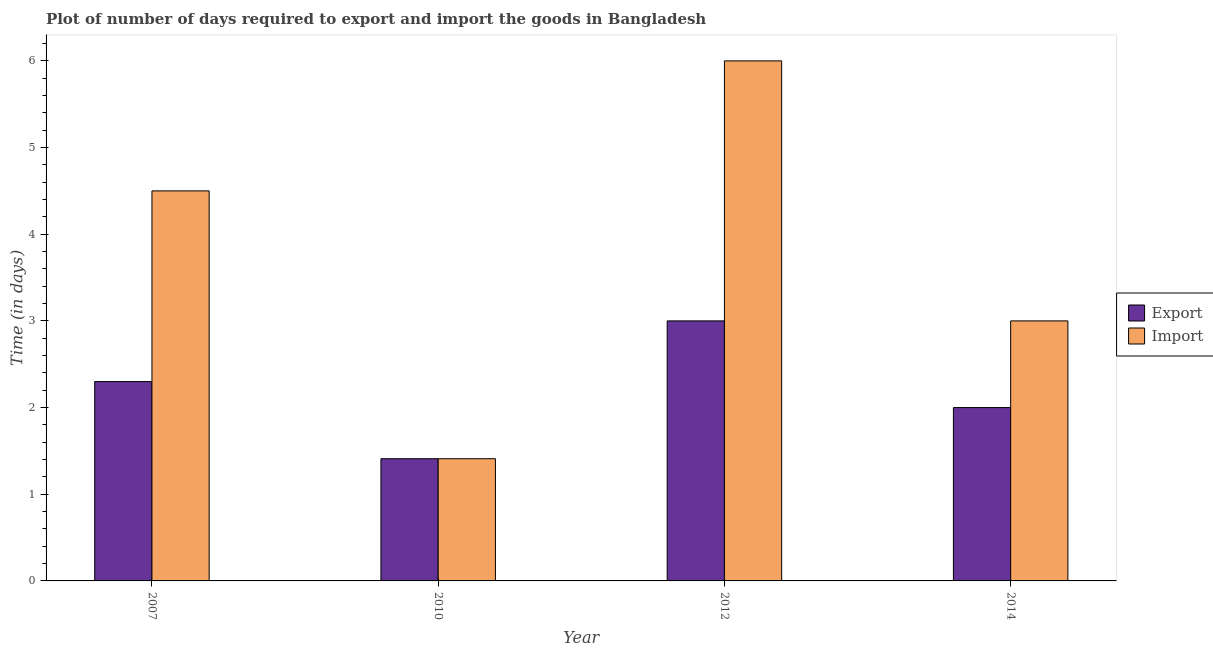Are the number of bars on each tick of the X-axis equal?
Provide a succinct answer. Yes. Across all years, what is the minimum time required to export?
Provide a short and direct response. 1.41. In which year was the time required to import maximum?
Ensure brevity in your answer.  2012. In which year was the time required to export minimum?
Provide a succinct answer. 2010. What is the total time required to import in the graph?
Offer a very short reply. 14.91. What is the difference between the time required to export in 2010 and that in 2012?
Offer a very short reply. -1.59. What is the difference between the time required to import in 2012 and the time required to export in 2007?
Your answer should be compact. 1.5. What is the average time required to export per year?
Your answer should be compact. 2.18. What is the ratio of the time required to export in 2010 to that in 2012?
Make the answer very short. 0.47. Is the time required to export in 2007 less than that in 2014?
Ensure brevity in your answer.  No. What is the difference between the highest and the second highest time required to import?
Make the answer very short. 1.5. What is the difference between the highest and the lowest time required to import?
Ensure brevity in your answer.  4.59. Is the sum of the time required to export in 2007 and 2010 greater than the maximum time required to import across all years?
Your response must be concise. Yes. What does the 1st bar from the left in 2012 represents?
Your answer should be compact. Export. What does the 1st bar from the right in 2012 represents?
Make the answer very short. Import. How many bars are there?
Keep it short and to the point. 8. Are all the bars in the graph horizontal?
Offer a very short reply. No. How many years are there in the graph?
Provide a short and direct response. 4. Are the values on the major ticks of Y-axis written in scientific E-notation?
Your answer should be compact. No. Does the graph contain grids?
Your answer should be very brief. No. How many legend labels are there?
Your answer should be compact. 2. What is the title of the graph?
Provide a short and direct response. Plot of number of days required to export and import the goods in Bangladesh. What is the label or title of the Y-axis?
Your answer should be very brief. Time (in days). What is the Time (in days) of Export in 2007?
Give a very brief answer. 2.3. What is the Time (in days) of Import in 2007?
Offer a very short reply. 4.5. What is the Time (in days) of Export in 2010?
Keep it short and to the point. 1.41. What is the Time (in days) in Import in 2010?
Offer a terse response. 1.41. What is the Time (in days) in Import in 2012?
Your answer should be compact. 6. What is the Time (in days) of Export in 2014?
Provide a short and direct response. 2. Across all years, what is the maximum Time (in days) in Import?
Offer a terse response. 6. Across all years, what is the minimum Time (in days) of Export?
Provide a succinct answer. 1.41. Across all years, what is the minimum Time (in days) in Import?
Your answer should be very brief. 1.41. What is the total Time (in days) of Export in the graph?
Give a very brief answer. 8.71. What is the total Time (in days) in Import in the graph?
Your answer should be very brief. 14.91. What is the difference between the Time (in days) of Export in 2007 and that in 2010?
Your answer should be very brief. 0.89. What is the difference between the Time (in days) in Import in 2007 and that in 2010?
Provide a succinct answer. 3.09. What is the difference between the Time (in days) in Import in 2007 and that in 2012?
Provide a short and direct response. -1.5. What is the difference between the Time (in days) in Export in 2007 and that in 2014?
Your answer should be compact. 0.3. What is the difference between the Time (in days) in Import in 2007 and that in 2014?
Offer a terse response. 1.5. What is the difference between the Time (in days) of Export in 2010 and that in 2012?
Make the answer very short. -1.59. What is the difference between the Time (in days) of Import in 2010 and that in 2012?
Offer a very short reply. -4.59. What is the difference between the Time (in days) in Export in 2010 and that in 2014?
Offer a very short reply. -0.59. What is the difference between the Time (in days) in Import in 2010 and that in 2014?
Your answer should be compact. -1.59. What is the difference between the Time (in days) in Export in 2012 and that in 2014?
Make the answer very short. 1. What is the difference between the Time (in days) in Import in 2012 and that in 2014?
Make the answer very short. 3. What is the difference between the Time (in days) in Export in 2007 and the Time (in days) in Import in 2010?
Offer a terse response. 0.89. What is the difference between the Time (in days) of Export in 2010 and the Time (in days) of Import in 2012?
Ensure brevity in your answer.  -4.59. What is the difference between the Time (in days) of Export in 2010 and the Time (in days) of Import in 2014?
Provide a succinct answer. -1.59. What is the average Time (in days) in Export per year?
Make the answer very short. 2.18. What is the average Time (in days) in Import per year?
Your answer should be compact. 3.73. In the year 2012, what is the difference between the Time (in days) of Export and Time (in days) of Import?
Keep it short and to the point. -3. What is the ratio of the Time (in days) of Export in 2007 to that in 2010?
Give a very brief answer. 1.63. What is the ratio of the Time (in days) in Import in 2007 to that in 2010?
Give a very brief answer. 3.19. What is the ratio of the Time (in days) in Export in 2007 to that in 2012?
Provide a short and direct response. 0.77. What is the ratio of the Time (in days) in Import in 2007 to that in 2012?
Your answer should be very brief. 0.75. What is the ratio of the Time (in days) in Export in 2007 to that in 2014?
Give a very brief answer. 1.15. What is the ratio of the Time (in days) of Export in 2010 to that in 2012?
Your response must be concise. 0.47. What is the ratio of the Time (in days) in Import in 2010 to that in 2012?
Keep it short and to the point. 0.23. What is the ratio of the Time (in days) in Export in 2010 to that in 2014?
Your answer should be compact. 0.7. What is the ratio of the Time (in days) of Import in 2010 to that in 2014?
Your response must be concise. 0.47. What is the ratio of the Time (in days) of Export in 2012 to that in 2014?
Offer a very short reply. 1.5. What is the ratio of the Time (in days) of Import in 2012 to that in 2014?
Offer a very short reply. 2. What is the difference between the highest and the second highest Time (in days) of Import?
Give a very brief answer. 1.5. What is the difference between the highest and the lowest Time (in days) of Export?
Your answer should be compact. 1.59. What is the difference between the highest and the lowest Time (in days) in Import?
Ensure brevity in your answer.  4.59. 